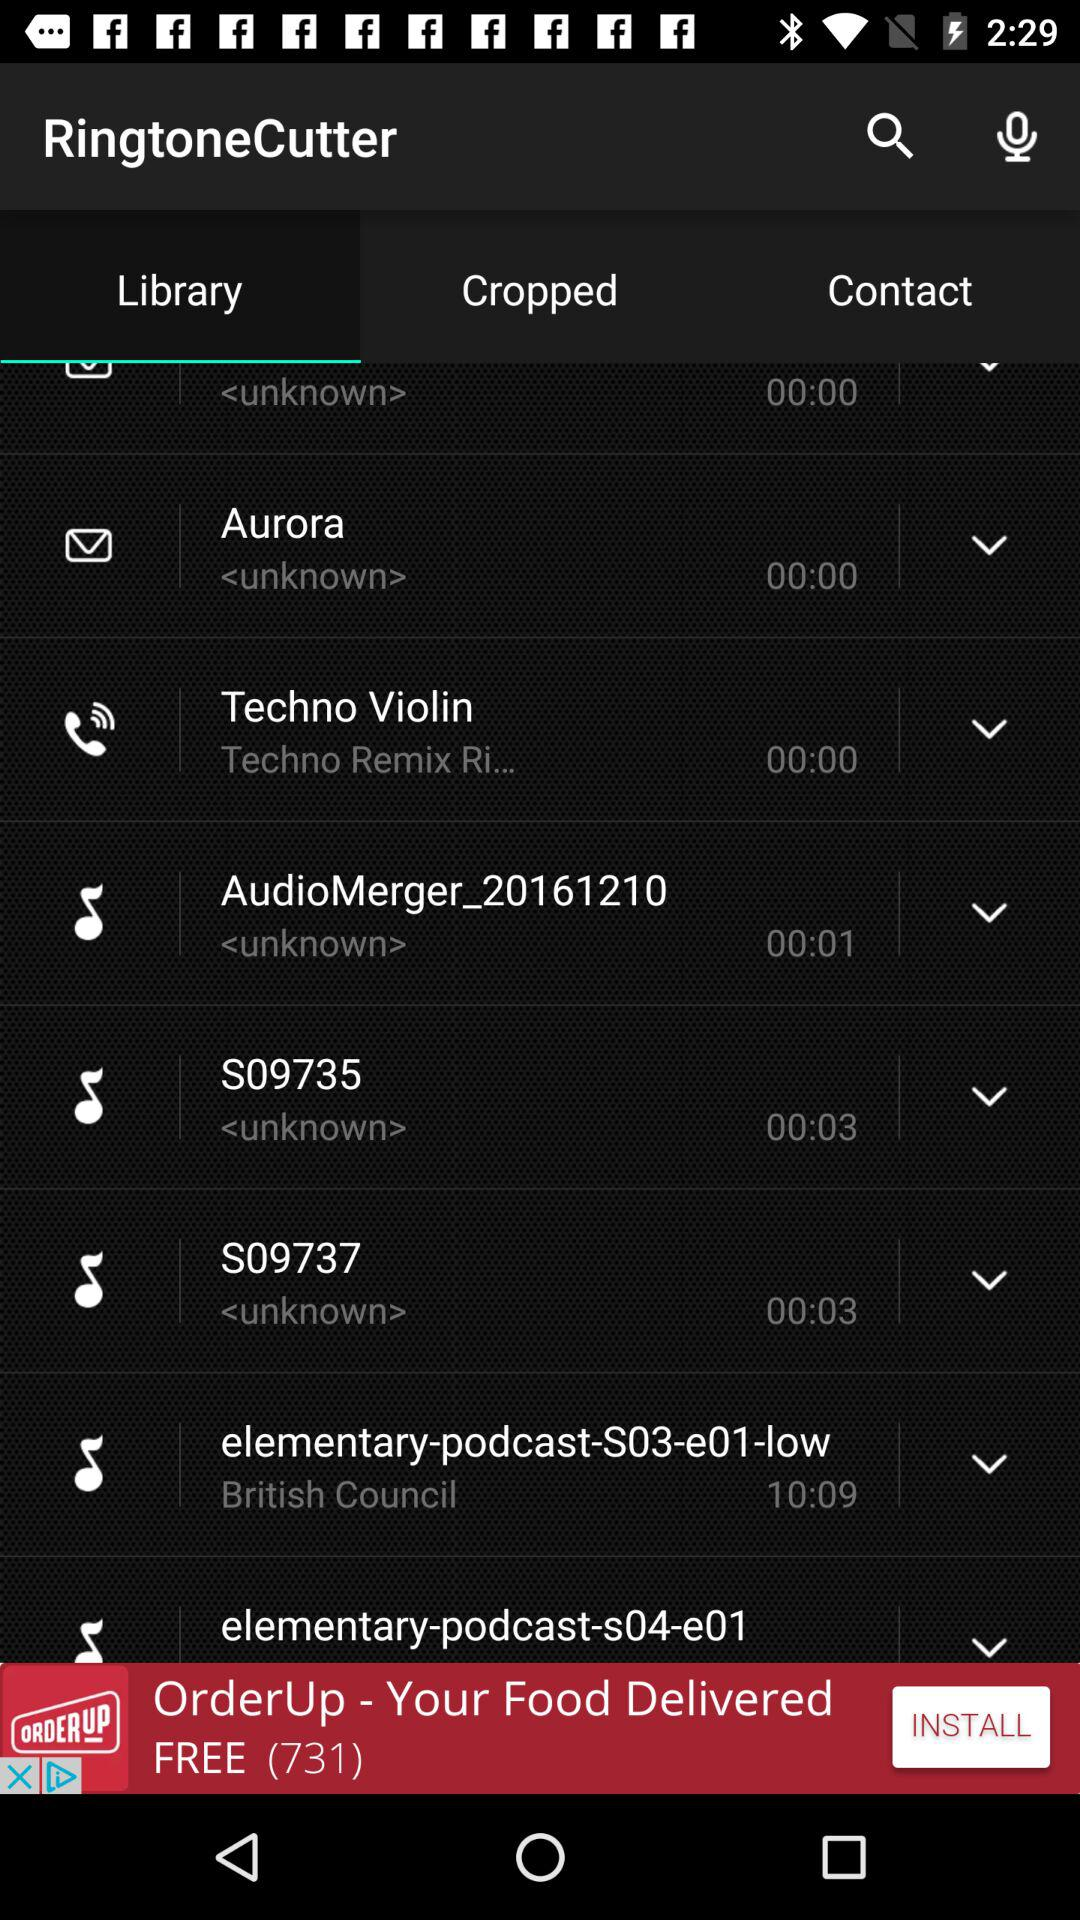What is the selected tab? The selected tab is "Library". 